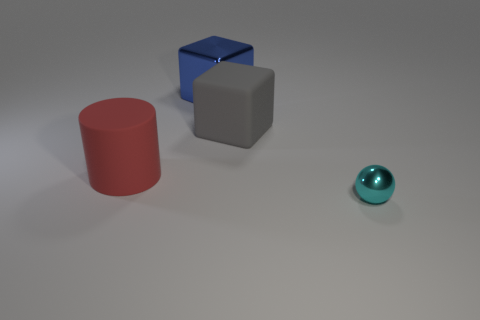Is there a cyan shiny thing? Yes, there is a small, cyan-colored shiny sphere located towards the right side of the image. It appears to be reflecting some light, which emphasizes its shiny texture. 